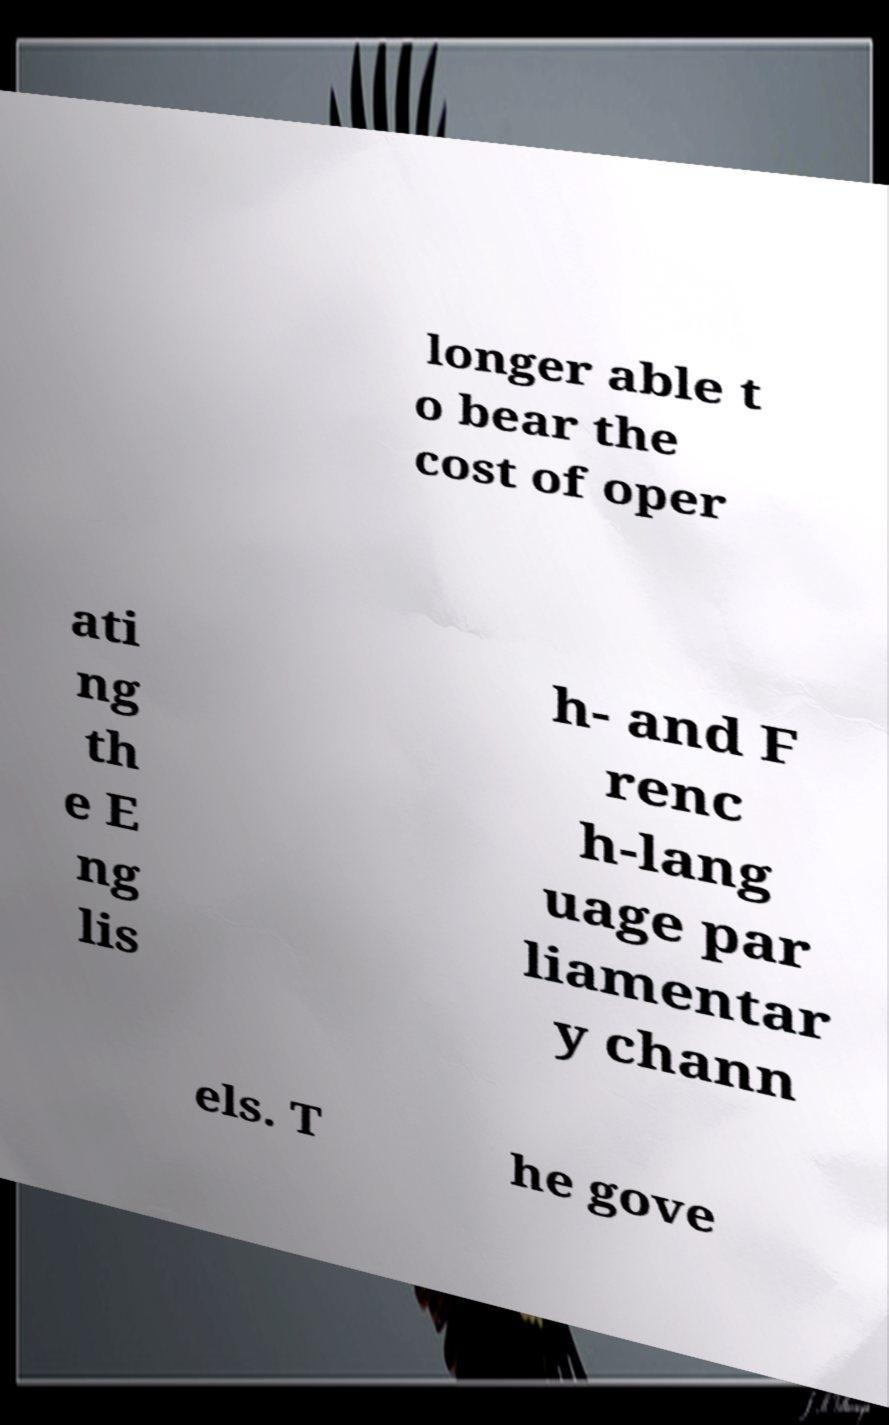Please identify and transcribe the text found in this image. longer able t o bear the cost of oper ati ng th e E ng lis h- and F renc h-lang uage par liamentar y chann els. T he gove 